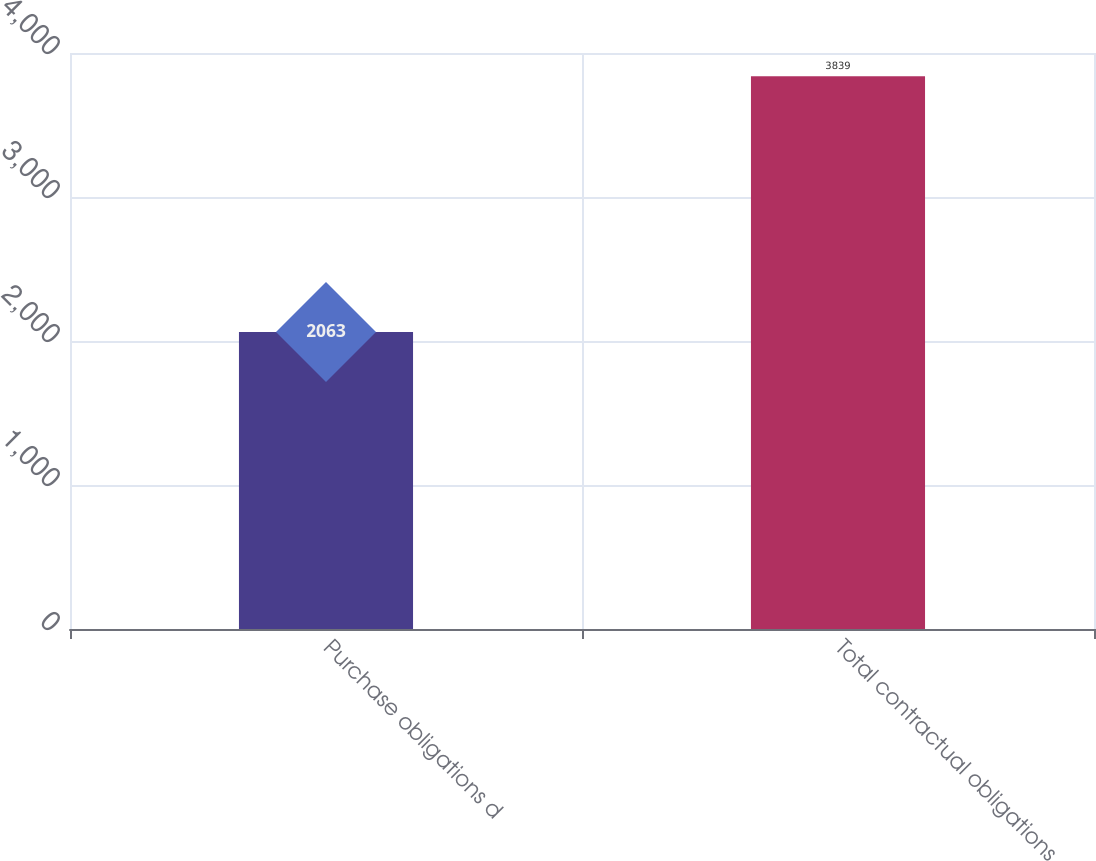<chart> <loc_0><loc_0><loc_500><loc_500><bar_chart><fcel>Purchase obligations d<fcel>Total contractual obligations<nl><fcel>2063<fcel>3839<nl></chart> 